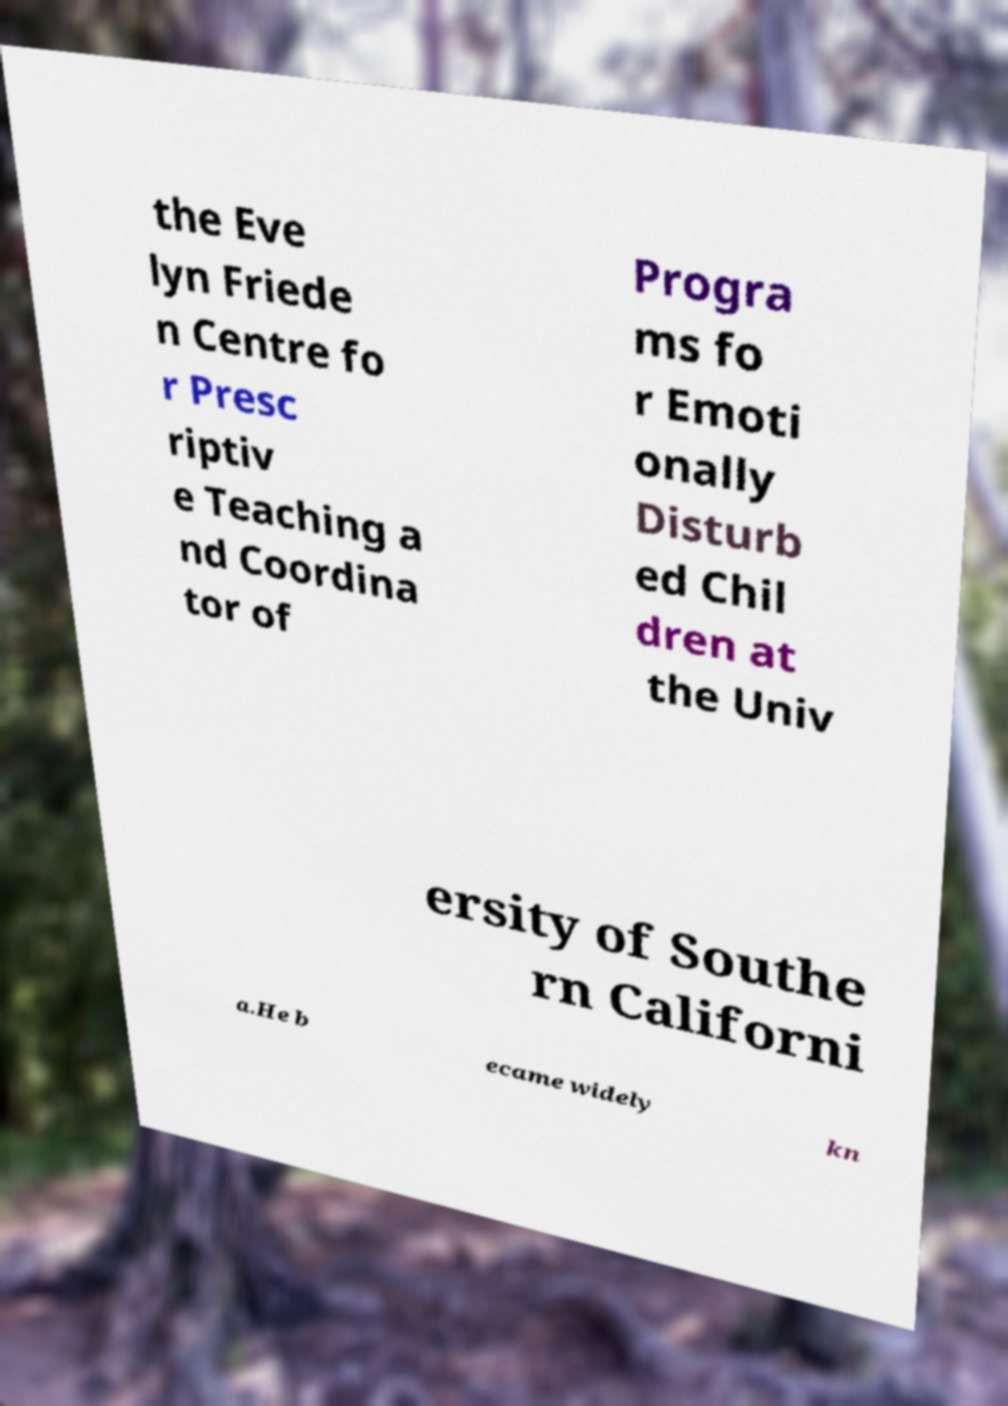What messages or text are displayed in this image? I need them in a readable, typed format. the Eve lyn Friede n Centre fo r Presc riptiv e Teaching a nd Coordina tor of Progra ms fo r Emoti onally Disturb ed Chil dren at the Univ ersity of Southe rn Californi a.He b ecame widely kn 